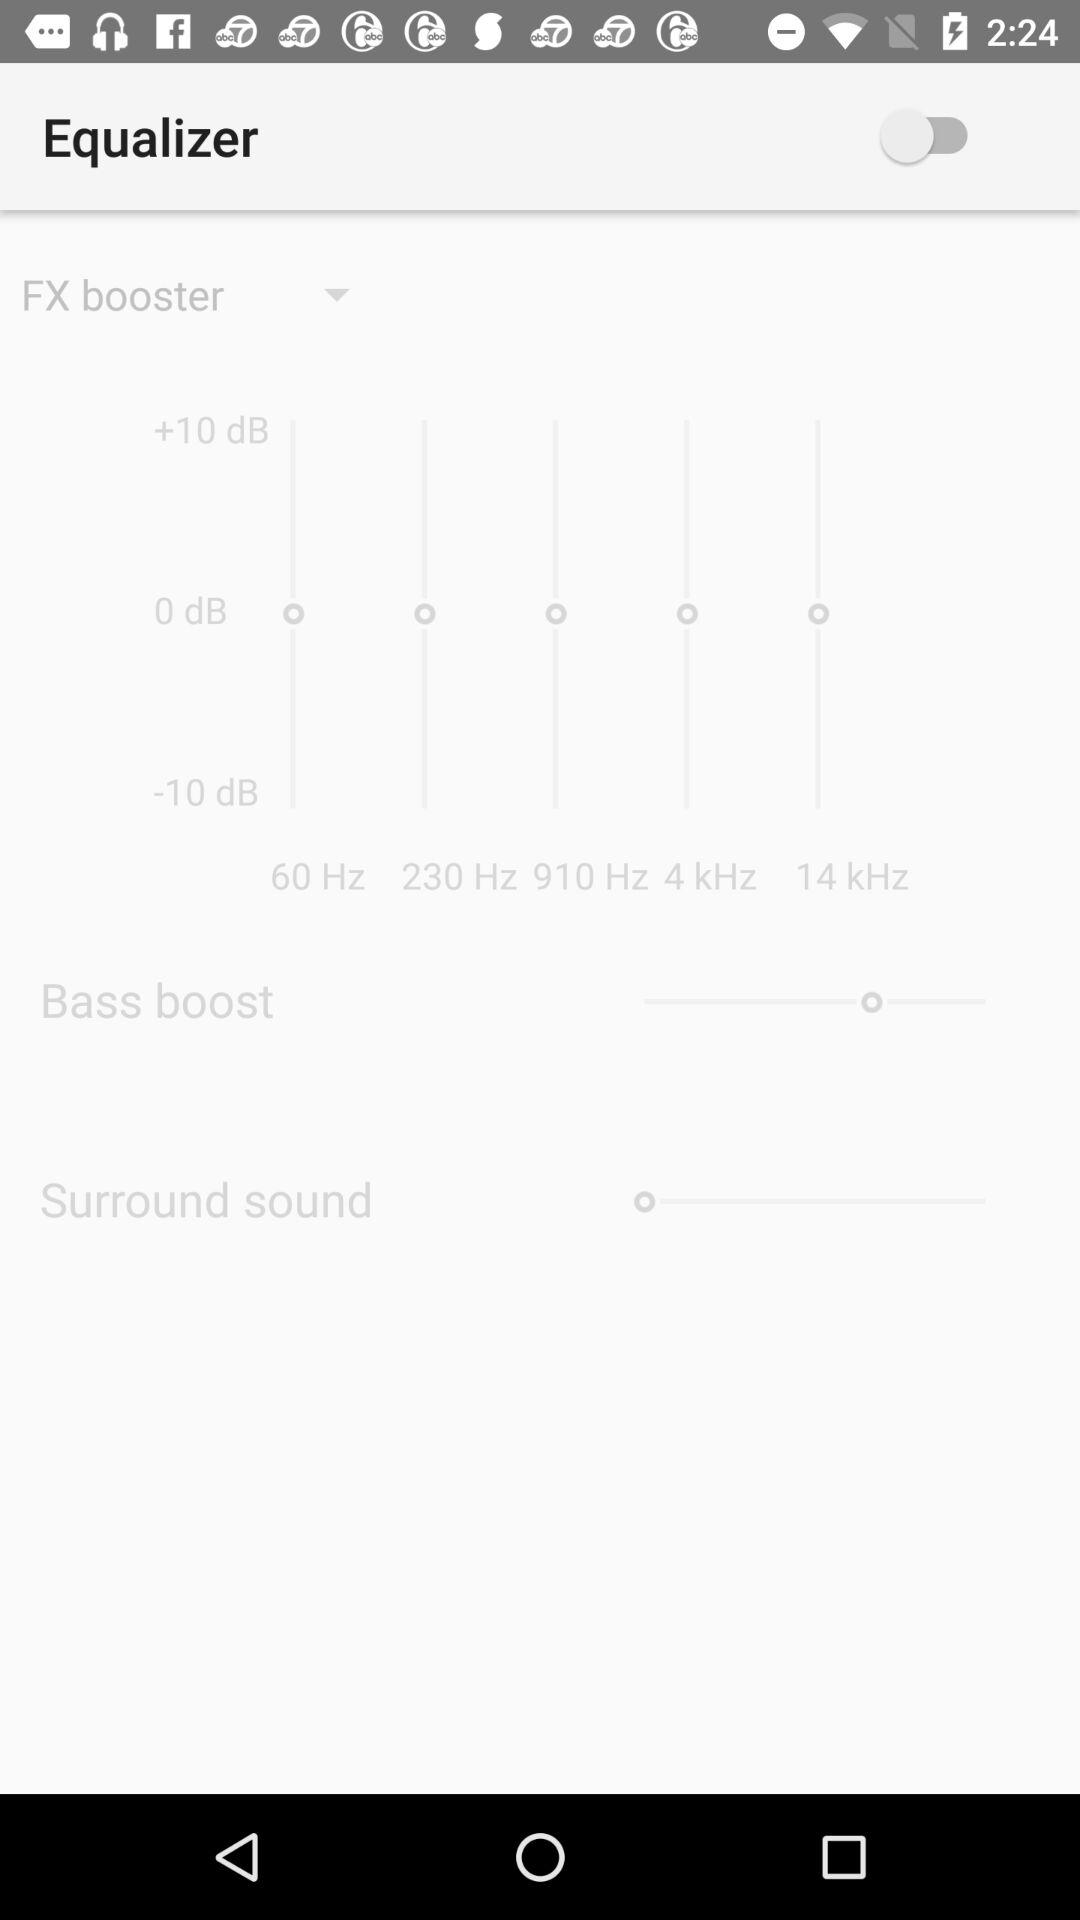What is the status of "Equalizer"? The status is "off". 